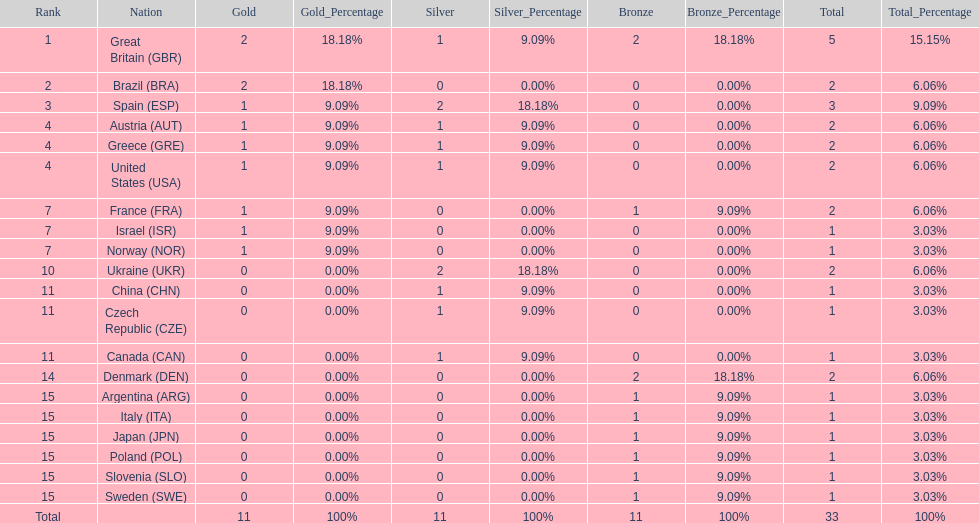What was the number of silver medals won by ukraine? 2. 